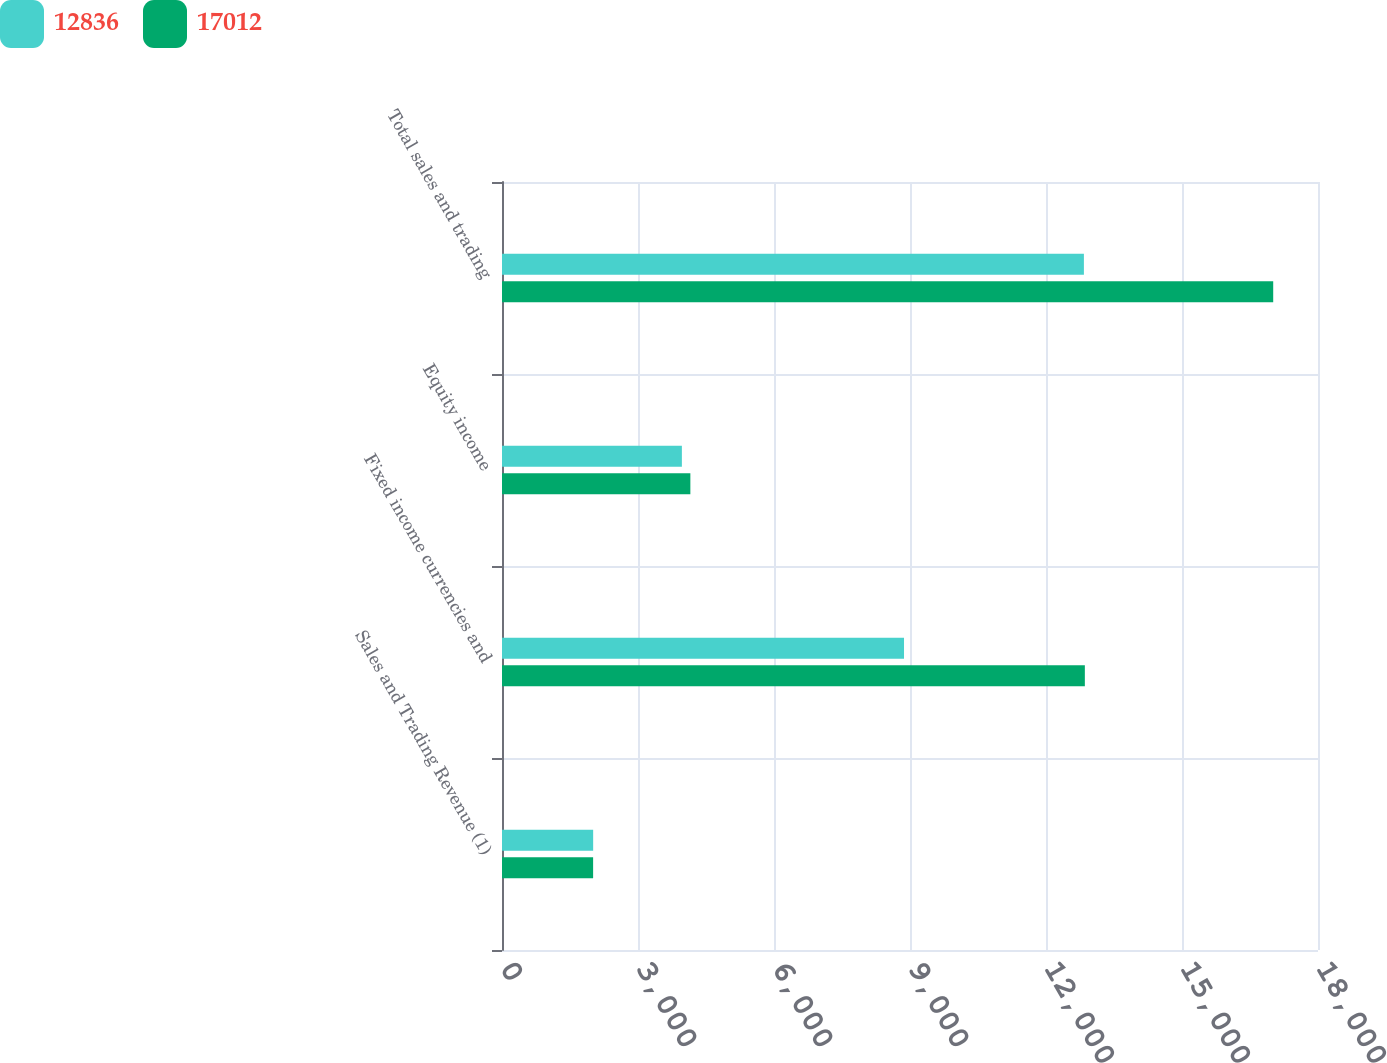Convert chart to OTSL. <chart><loc_0><loc_0><loc_500><loc_500><stacked_bar_chart><ecel><fcel>Sales and Trading Revenue (1)<fcel>Fixed income currencies and<fcel>Equity income<fcel>Total sales and trading<nl><fcel>12836<fcel>2011<fcel>8868<fcel>3968<fcel>12836<nl><fcel>17012<fcel>2010<fcel>12857<fcel>4155<fcel>17012<nl></chart> 